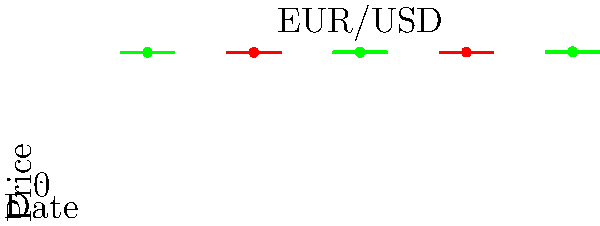As a financial advisor specializing in forex markets, analyze the given EUR/USD candlestick chart. What pattern does the last three candlesticks form, and what does it suggest about potential future price movement? To analyze the candlestick pattern and its implications, let's follow these steps:

1. Identify the last three candlesticks:
   - Third-to-last (Day 3): A long green (bullish) candlestick
   - Second-to-last (Day 4): A red (bearish) candlestick with a smaller body
   - Last (Day 5): A green (bullish) candlestick that closes above the high of the previous two candlesticks

2. Recognize the pattern:
   This formation is known as a "Morning Star" pattern. It's a bullish reversal pattern that typically occurs at the bottom of a downtrend.

3. Understand the components:
   - The first long red candle represents a continuation of the existing downtrend
   - The second smaller candle (either color) shows indecision in the market
   - The third green candle that closes above the midpoint of the first candle confirms the reversal

4. Interpret the pattern:
   The Morning Star pattern suggests that the market sentiment has shifted from bearish to bullish. It indicates that buyers have regained control after a period of selling pressure.

5. Consider the implications:
   This pattern often signals the potential for an upward price movement in the near future. Traders and investors might see this as an opportunity to enter long positions or exit short positions.

6. Factor in the currency pair:
   As this is the EUR/USD pair, the pattern suggests that the Euro may strengthen against the US Dollar in the coming trading sessions.

7. Remember the limitations:
   While candlestick patterns can be powerful indicators, they should not be used in isolation. It's important to consider other technical indicators, fundamental analysis, and overall market conditions before making trading decisions.
Answer: Morning Star pattern; suggests potential bullish reversal 